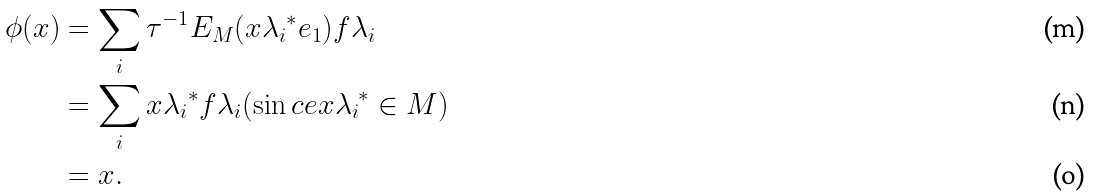Convert formula to latex. <formula><loc_0><loc_0><loc_500><loc_500>\phi ( x ) & = \sum _ { i } { \tau } ^ { - 1 } E _ { M } ( x { \lambda _ { i } } ^ { * } e _ { 1 } ) f { \lambda _ { i } } \\ & = \sum _ { i } x { \lambda _ { i } } ^ { * } f { \lambda _ { i } } ( \sin c e x { \lambda _ { i } } ^ { * } \in M ) \\ & = x .</formula> 